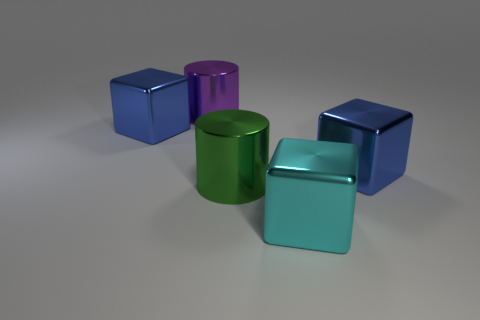The big blue block to the right of the big cube left of the big purple object is made of what material?
Keep it short and to the point. Metal. Does the purple thing have the same material as the large cylinder right of the purple thing?
Your answer should be very brief. Yes. What number of things are large objects that are in front of the purple cylinder or big green rubber blocks?
Your answer should be compact. 4. There is a large green thing; does it have the same shape as the big cyan metal thing to the right of the purple metal cylinder?
Offer a very short reply. No. How many big blocks are both behind the cyan metallic cube and right of the large purple shiny cylinder?
Ensure brevity in your answer.  1. What material is the purple thing that is the same shape as the large green shiny object?
Offer a very short reply. Metal. What size is the cube behind the blue metallic object that is right of the big cyan object?
Offer a very short reply. Large. Is there a shiny thing?
Your answer should be very brief. Yes. What is the material of the object that is on the left side of the large green cylinder and in front of the large purple metal cylinder?
Keep it short and to the point. Metal. Are there more blue metallic blocks that are left of the green object than cyan metal cubes that are right of the big cyan metal thing?
Offer a very short reply. Yes. 